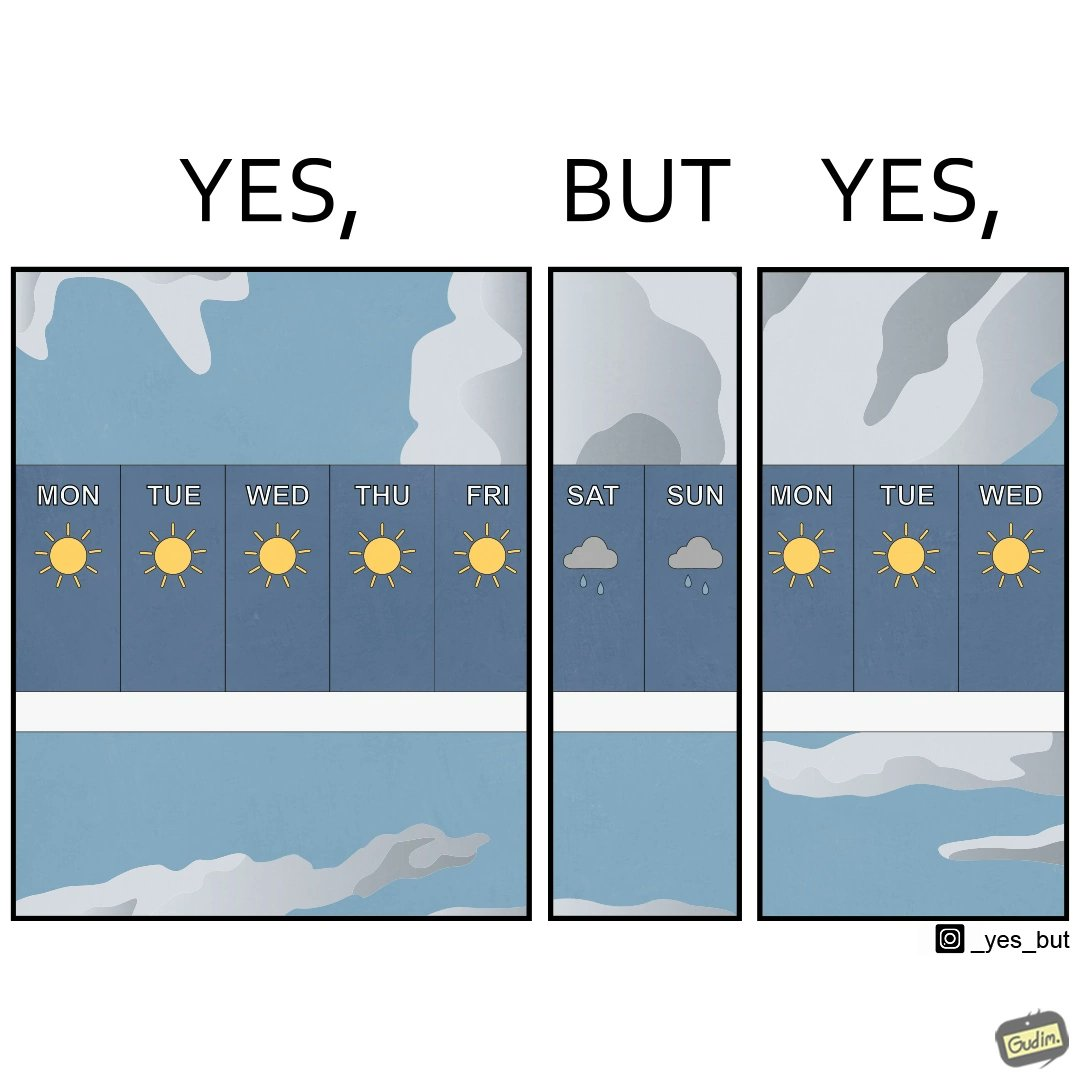Would you classify this image as satirical? Yes, this image is satirical. 